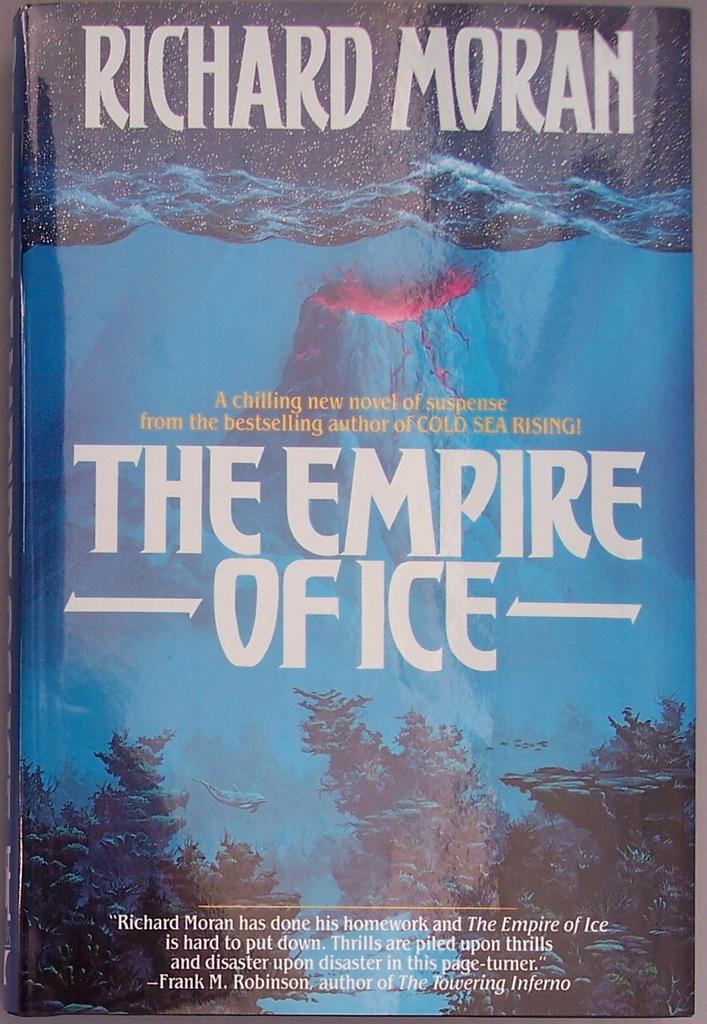Who wrote this?
Ensure brevity in your answer.  Richard moran. 